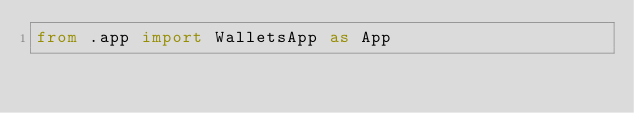Convert code to text. <code><loc_0><loc_0><loc_500><loc_500><_Python_>from .app import WalletsApp as App
</code> 